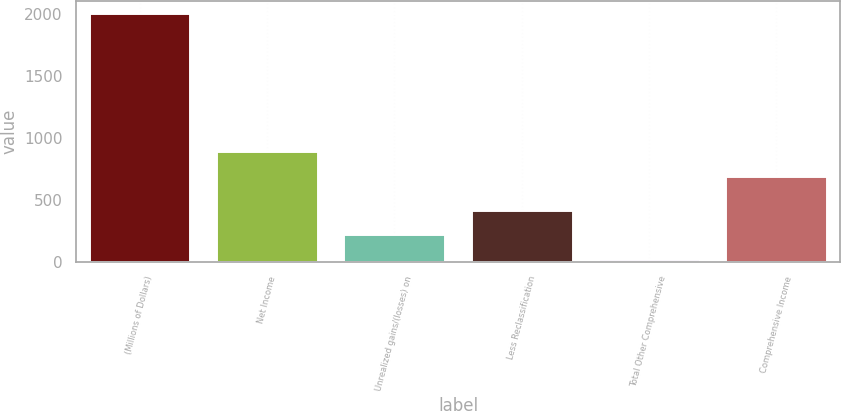Convert chart to OTSL. <chart><loc_0><loc_0><loc_500><loc_500><bar_chart><fcel>(Millions of Dollars)<fcel>Net Income<fcel>Unrealized gains/(losses) on<fcel>Less Reclassification<fcel>Total Other Comprehensive<fcel>Comprehensive Income<nl><fcel>2005<fcel>892<fcel>223<fcel>421<fcel>25<fcel>694<nl></chart> 